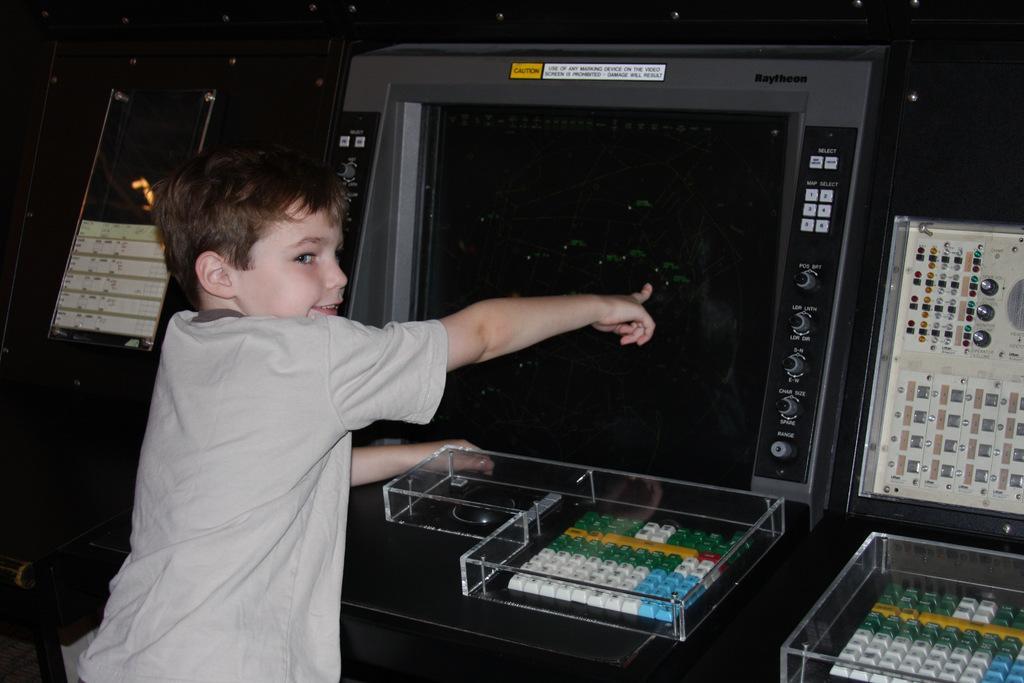Describe this image in one or two sentences. In the image in the center, we can see one kid standing and smiling. In front of him, we can see keyboards, boxes, machine and a few other objects. 